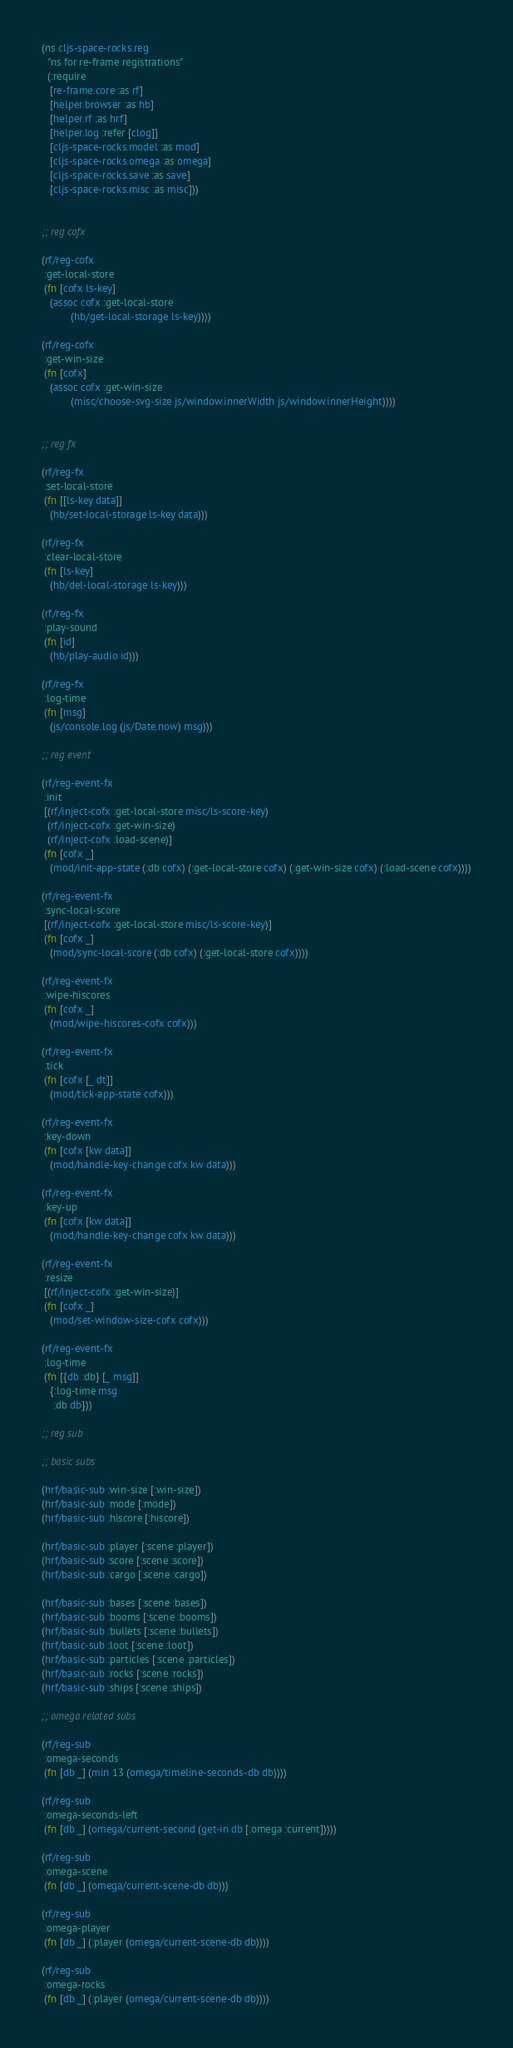Convert code to text. <code><loc_0><loc_0><loc_500><loc_500><_Clojure_>(ns cljs-space-rocks.reg
  "ns for re-frame registrations"
  (:require
   [re-frame.core :as rf]
   [helper.browser :as hb]
   [helper.rf :as hrf]
   [helper.log :refer [clog]]
   [cljs-space-rocks.model :as mod]
   [cljs-space-rocks.omega :as omega]
   [cljs-space-rocks.save :as save]
   [cljs-space-rocks.misc :as misc]))


;; reg cofx

(rf/reg-cofx
 :get-local-store
 (fn [cofx ls-key]
   (assoc cofx :get-local-store
          (hb/get-local-storage ls-key))))

(rf/reg-cofx
 :get-win-size
 (fn [cofx]
   (assoc cofx :get-win-size
          (misc/choose-svg-size js/window.innerWidth js/window.innerHeight))))


;; reg fx

(rf/reg-fx
 :set-local-store
 (fn [[ls-key data]]
   (hb/set-local-storage ls-key data)))

(rf/reg-fx
 :clear-local-store
 (fn [ls-key]
   (hb/del-local-storage ls-key)))

(rf/reg-fx
 :play-sound
 (fn [id]
   (hb/play-audio id)))

(rf/reg-fx
 :log-time
 (fn [msg]
   (js/console.log (js/Date.now) msg)))

;; reg event

(rf/reg-event-fx
 :init
 [(rf/inject-cofx :get-local-store misc/ls-score-key)
  (rf/inject-cofx :get-win-size)
  (rf/inject-cofx :load-scene)]
 (fn [cofx _]
   (mod/init-app-state (:db cofx) (:get-local-store cofx) (:get-win-size cofx) (:load-scene cofx))))

(rf/reg-event-fx
 :sync-local-score
 [(rf/inject-cofx :get-local-store misc/ls-score-key)]
 (fn [cofx _]
   (mod/sync-local-score (:db cofx) (:get-local-store cofx))))

(rf/reg-event-fx
 :wipe-hiscores
 (fn [cofx _]
   (mod/wipe-hiscores-cofx cofx)))

(rf/reg-event-fx
 :tick
 (fn [cofx [_ dt]]
   (mod/tick-app-state cofx)))

(rf/reg-event-fx
 :key-down
 (fn [cofx [kw data]]
   (mod/handle-key-change cofx kw data)))

(rf/reg-event-fx
 :key-up
 (fn [cofx [kw data]]
   (mod/handle-key-change cofx kw data)))

(rf/reg-event-fx
 :resize
 [(rf/inject-cofx :get-win-size)]
 (fn [cofx _]
   (mod/set-window-size-cofx cofx)))

(rf/reg-event-fx
 :log-time
 (fn [{db :db} [_ msg]]
   {:log-time msg
    :db db}))

;; reg sub

;; basic subs

(hrf/basic-sub :win-size [:win-size])
(hrf/basic-sub :mode [:mode])
(hrf/basic-sub :hiscore [:hiscore])

(hrf/basic-sub :player [:scene :player])
(hrf/basic-sub :score [:scene :score])
(hrf/basic-sub :cargo [:scene :cargo])

(hrf/basic-sub :bases [:scene :bases])
(hrf/basic-sub :booms [:scene :booms])
(hrf/basic-sub :bullets [:scene :bullets])
(hrf/basic-sub :loot [:scene :loot])
(hrf/basic-sub :particles [:scene :particles])
(hrf/basic-sub :rocks [:scene :rocks])
(hrf/basic-sub :ships [:scene :ships])

;; omega related subs

(rf/reg-sub
 :omega-seconds
 (fn [db _] (min 13 (omega/timeline-seconds-db db))))

(rf/reg-sub
 :omega-seconds-left
 (fn [db _] (omega/current-second (get-in db [:omega :current]))))

(rf/reg-sub
 :omega-scene
 (fn [db _] (omega/current-scene-db db)))

(rf/reg-sub
 :omega-player
 (fn [db _] (:player (omega/current-scene-db db))))

(rf/reg-sub
 :omega-rocks
 (fn [db _] (:player (omega/current-scene-db db))))
</code> 